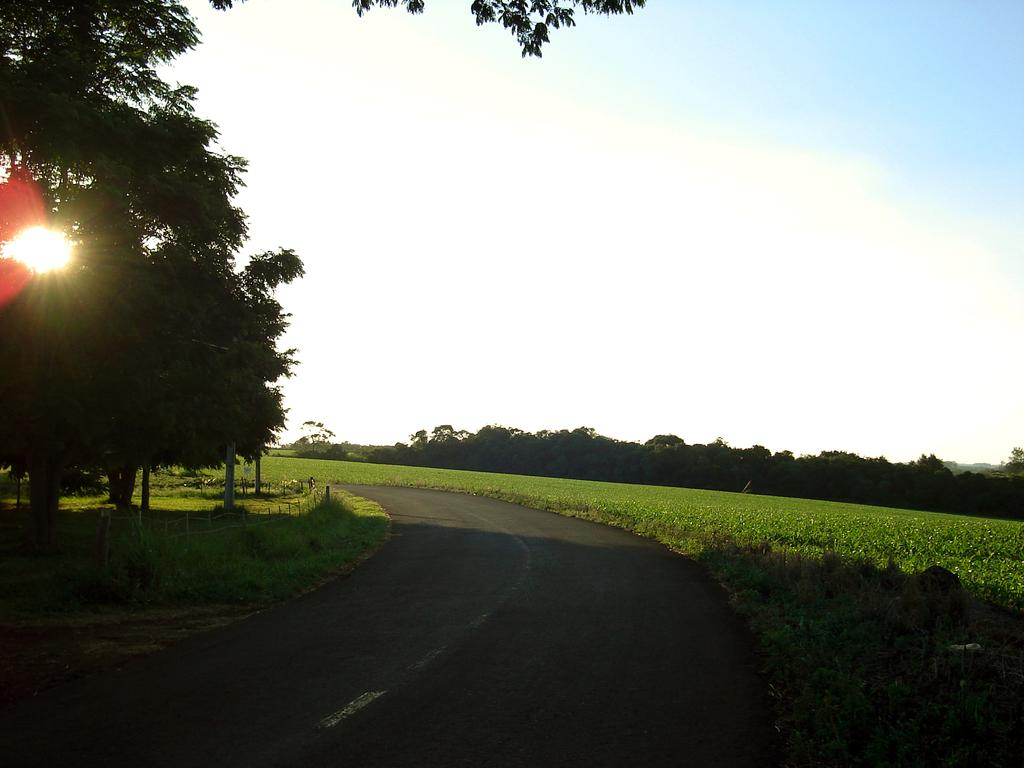What type of surface can be seen in the image? There is a road in the image. What type of vegetation is present in the image? There are plants, grass, and trees in the image. What type of barrier is visible in the image? There is a fence in the image. What is visible in the background of the image? The sky is visible in the background of the image. How many chairs are placed around the chicken in the image? There are no chairs or chicken present in the image. What type of fowl can be seen interacting with the plants in the image? There is no fowl present in the image; only plants, grass, trees, a road, a fence, and the sky are visible. 